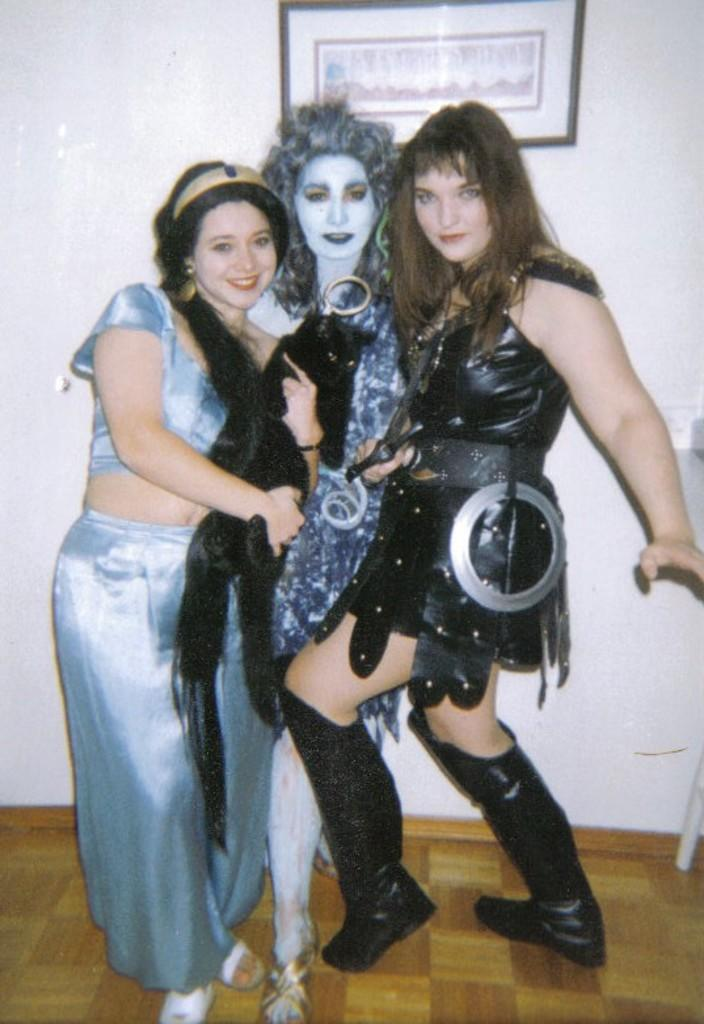What are the people in the image doing? The persons standing in the image are smiling. Can you describe the background of the image? There is a wall in the background of the image. What is on the wall in the background? There is a frame on the wall in the background. What type of sack can be seen in the image? There is no sack present in the image. What page of the book are the persons reading in the image? There is no book or page visible in the image. 